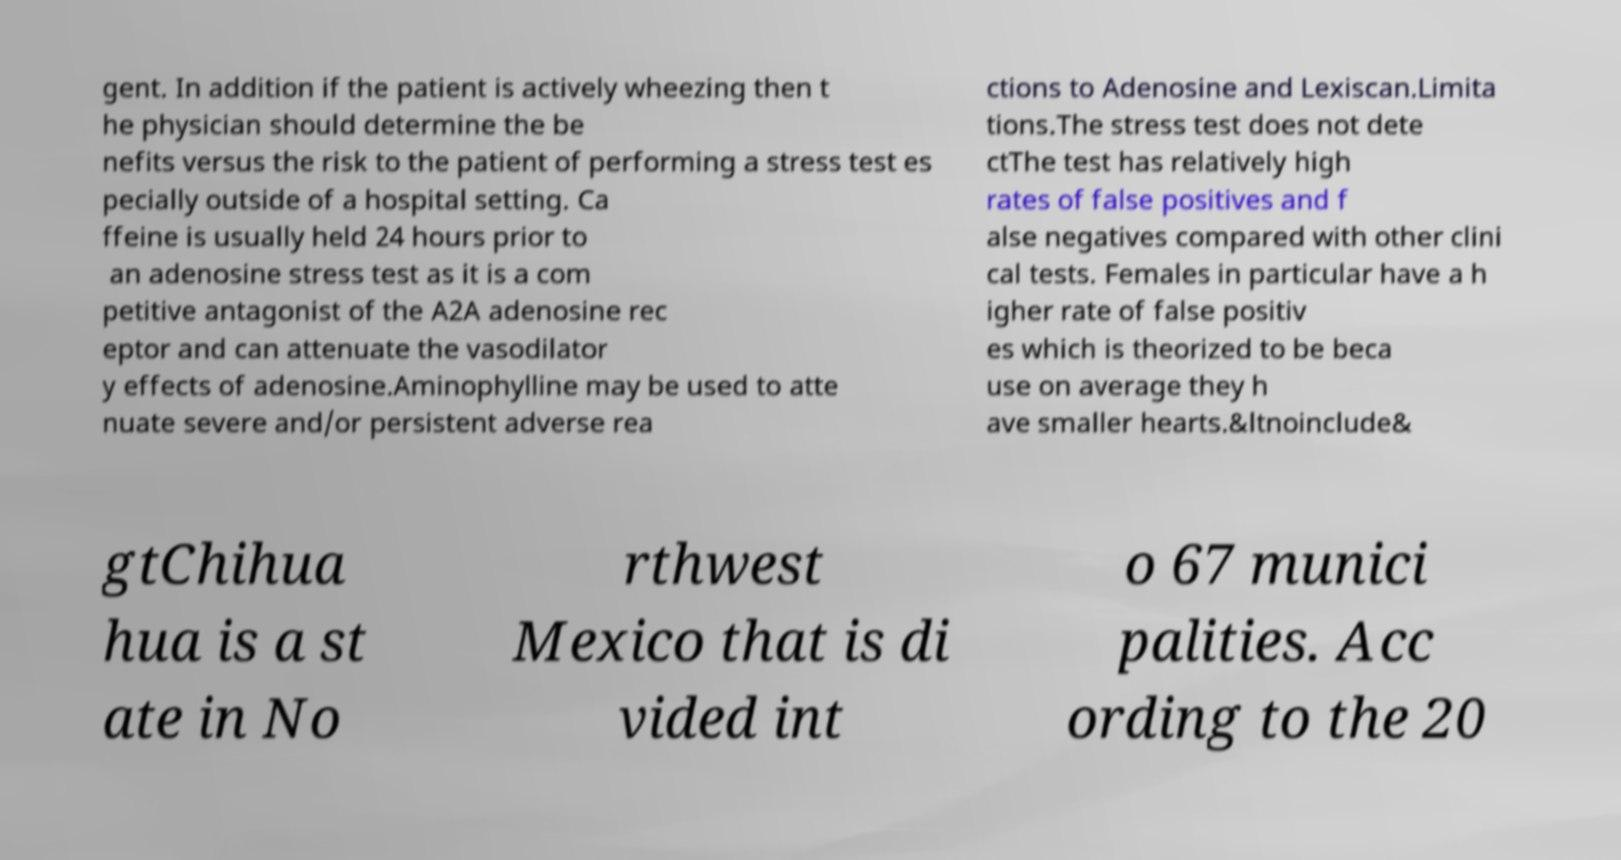Can you read and provide the text displayed in the image?This photo seems to have some interesting text. Can you extract and type it out for me? gent. In addition if the patient is actively wheezing then t he physician should determine the be nefits versus the risk to the patient of performing a stress test es pecially outside of a hospital setting. Ca ffeine is usually held 24 hours prior to an adenosine stress test as it is a com petitive antagonist of the A2A adenosine rec eptor and can attenuate the vasodilator y effects of adenosine.Aminophylline may be used to atte nuate severe and/or persistent adverse rea ctions to Adenosine and Lexiscan.Limita tions.The stress test does not dete ctThe test has relatively high rates of false positives and f alse negatives compared with other clini cal tests. Females in particular have a h igher rate of false positiv es which is theorized to be beca use on average they h ave smaller hearts.&ltnoinclude& gtChihua hua is a st ate in No rthwest Mexico that is di vided int o 67 munici palities. Acc ording to the 20 